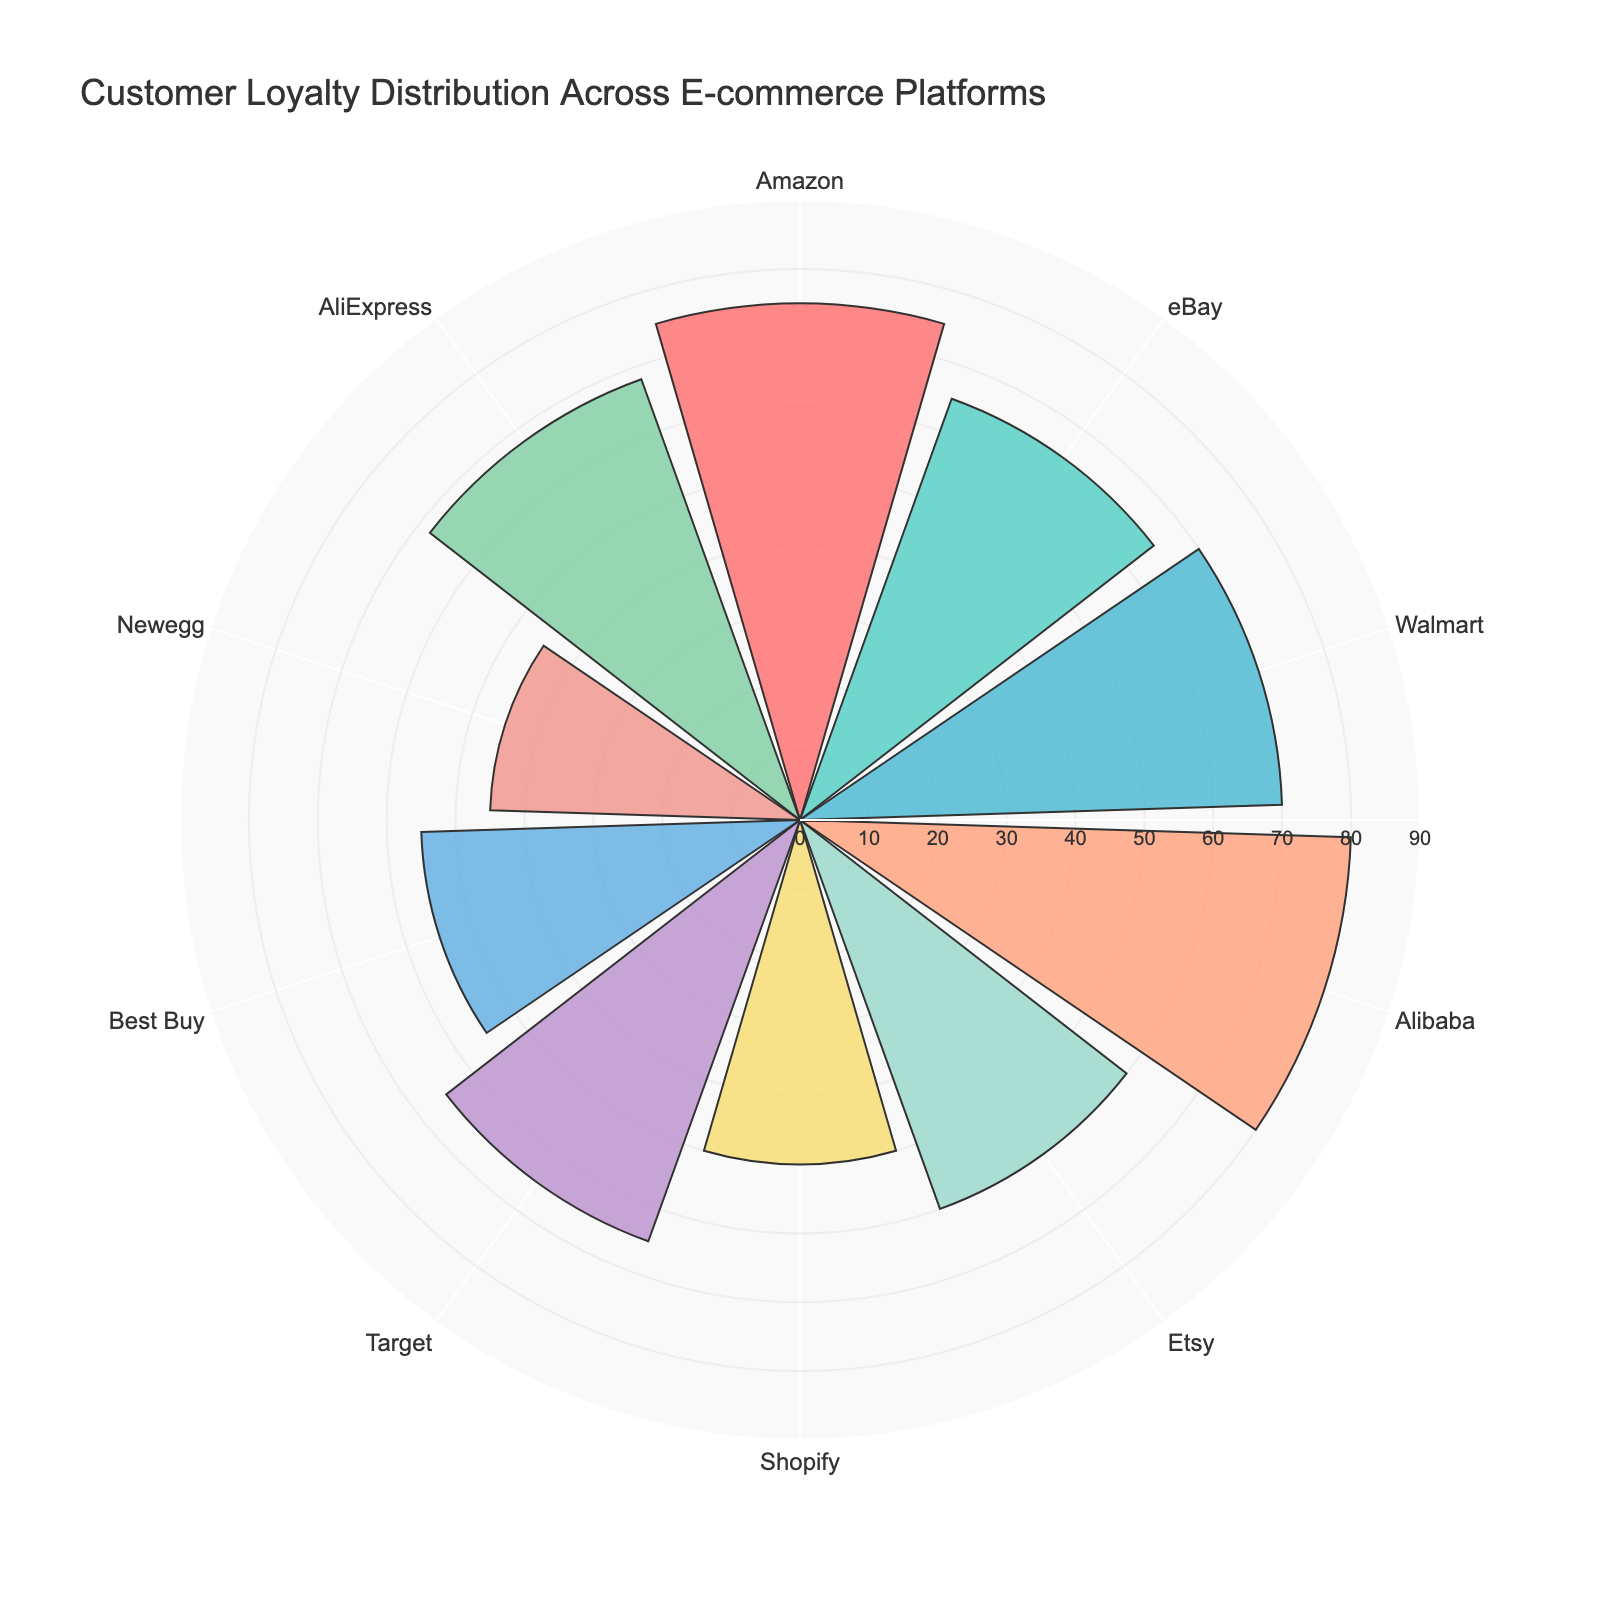What is the title of the figure? The title is usually placed at the top of the chart and provides a summary of what the chart represents.
Answer: Customer Loyalty Distribution Across E-commerce Platforms What is the range of the radial axis in the chart? The radial axis range can be found by looking at the numbers along the radial grid lines.
Answer: 0 to 90 Which platform has the highest customer loyalty score? By looking at the bars, the tallest bar represents the platform with the highest score.
Answer: Alibaba How many platforms have a customer loyalty score of 65? Count the number of bars that reach the 65 level on the radial axis.
Answer: 2 (eBay and Target) What is the difference in customer loyalty scores between Amazon and Newegg? Find the heights of the bars for Amazon and Newegg, then calculate the difference.
Answer: 30 What color represents Walmart on the chart? Identify the section labeled "Walmart" and note its color.
Answer: Light salmon (or '#FFA07A') What is the second highest customer loyalty score and which platform does it belong to? Identify the heights of the bars and find the second tallest one.
Answer: Amazon with a score of 75 Which platform has the lowest customer loyalty score? Identify the shortest bar in the chart.
Answer: Newegg What's the average customer loyalty score across all platforms? Sum all the scores and divide by the number of platforms. Sum: 75 + 65 + 70 + 80 + 60 + 50 + 65 + 55 + 45 + 68 = 633. Average: 633 / 10 = 63.3
Answer: 63.3 How many platforms have a customer loyalty score higher than 70? Count the number of bars that go beyond the 70 mark on the radial axis.
Answer: 2 (Alibaba and Amazon) 